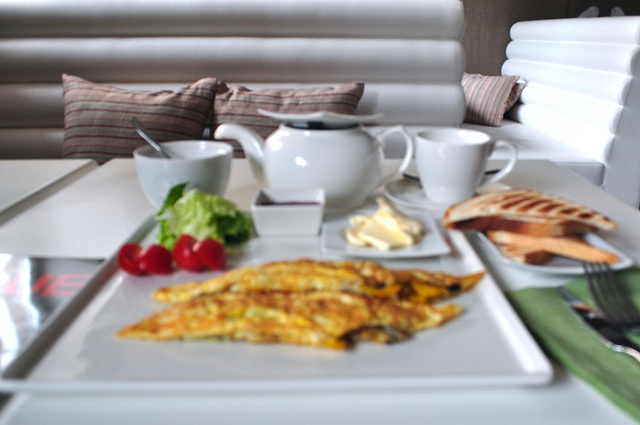Describe the objects in this image and their specific colors. I can see dining table in white, darkgray, lightgray, and gray tones, couch in white, gray, darkgray, and lightgray tones, chair in white, darkgray, and gray tones, pizza in white, olive, tan, and orange tones, and pizza in white, olive, tan, and orange tones in this image. 